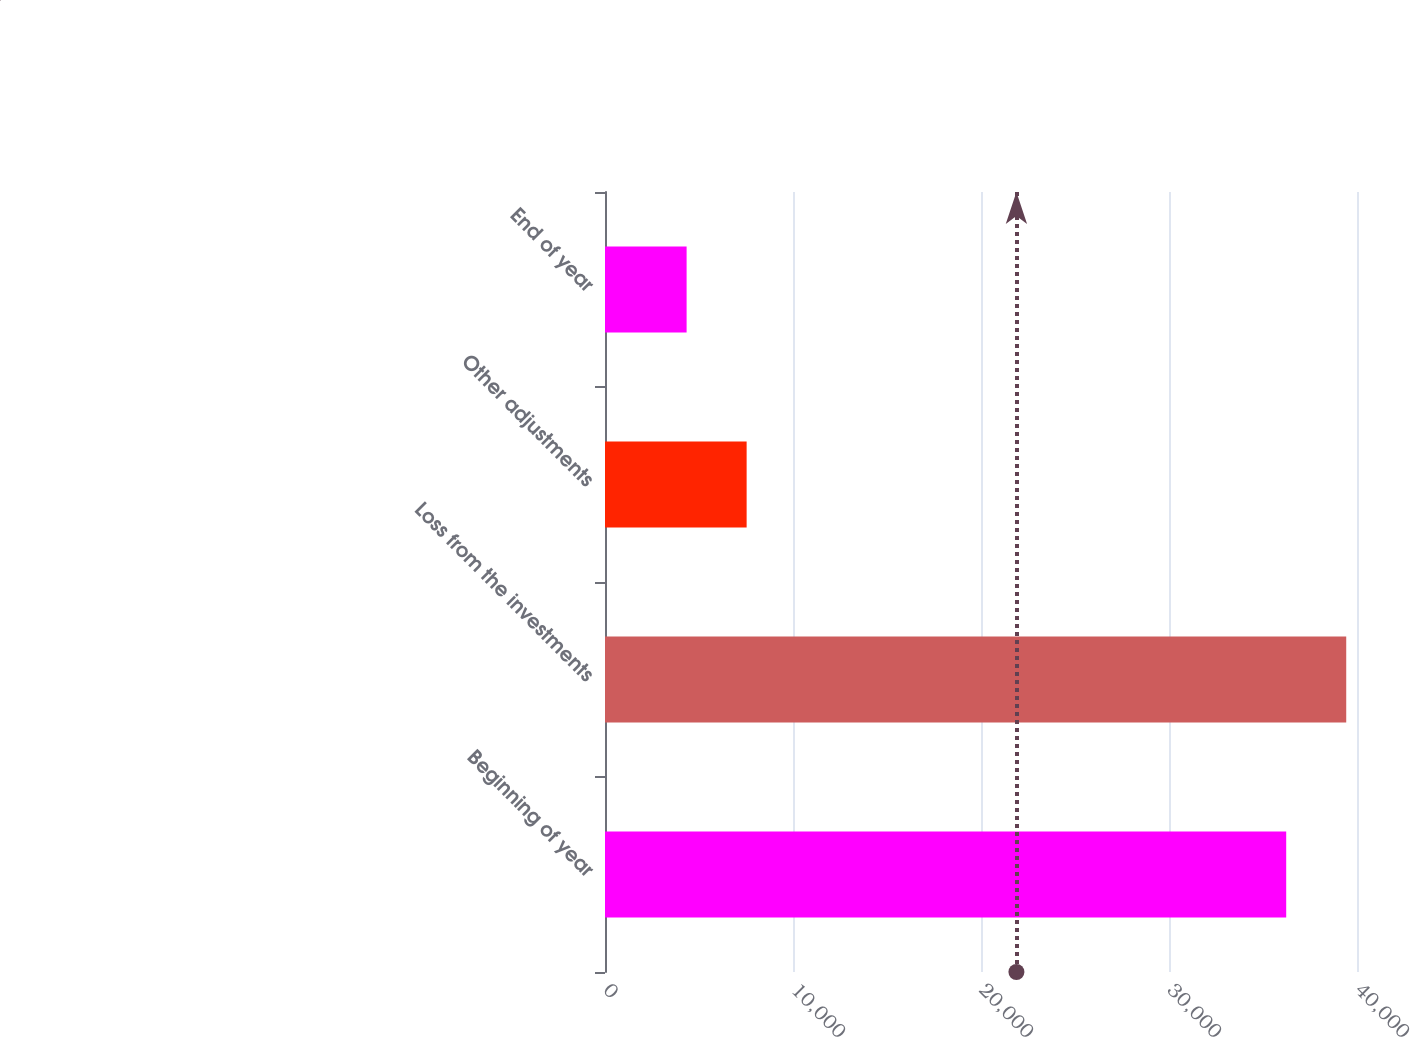Convert chart to OTSL. <chart><loc_0><loc_0><loc_500><loc_500><bar_chart><fcel>Beginning of year<fcel>Loss from the investments<fcel>Other adjustments<fcel>End of year<nl><fcel>36234<fcel>39426.8<fcel>7533.8<fcel>4341<nl></chart> 